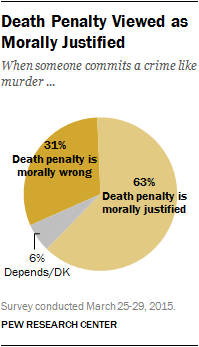Specify some key components in this picture. The largest segment value is greater than the sum of the two smallest segments. The smallest segment is gray. 